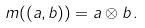Convert formula to latex. <formula><loc_0><loc_0><loc_500><loc_500>m ( ( a , b ) ) = a \otimes b \, .</formula> 